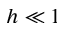Convert formula to latex. <formula><loc_0><loc_0><loc_500><loc_500>h \ll 1</formula> 